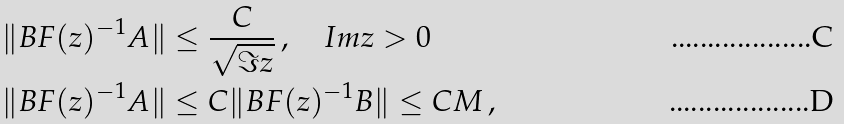Convert formula to latex. <formula><loc_0><loc_0><loc_500><loc_500>& \| B F ( z ) ^ { - 1 } A \| \leq \frac { C } { \sqrt { \Im z } } \, , \quad I m z > 0 \\ & \| B F ( z ) ^ { - 1 } A \| \leq C \| B F ( z ) ^ { - 1 } B \| \leq C M \, ,</formula> 